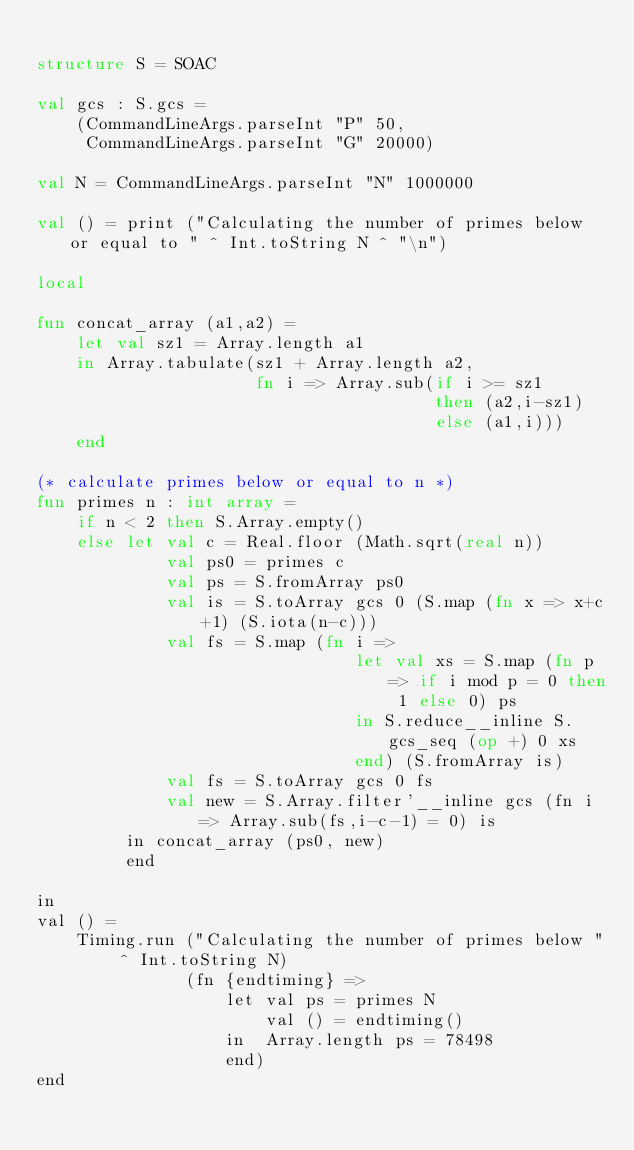Convert code to text. <code><loc_0><loc_0><loc_500><loc_500><_SML_>
structure S = SOAC

val gcs : S.gcs =
    (CommandLineArgs.parseInt "P" 50,
     CommandLineArgs.parseInt "G" 20000)

val N = CommandLineArgs.parseInt "N" 1000000

val () = print ("Calculating the number of primes below or equal to " ^ Int.toString N ^ "\n")

local

fun concat_array (a1,a2) =
    let val sz1 = Array.length a1
    in Array.tabulate(sz1 + Array.length a2,
                      fn i => Array.sub(if i >= sz1
                                        then (a2,i-sz1)
                                        else (a1,i)))
    end

(* calculate primes below or equal to n *)
fun primes n : int array =
    if n < 2 then S.Array.empty()
    else let val c = Real.floor (Math.sqrt(real n))
             val ps0 = primes c
             val ps = S.fromArray ps0
             val is = S.toArray gcs 0 (S.map (fn x => x+c+1) (S.iota(n-c)))
             val fs = S.map (fn i =>
                                let val xs = S.map (fn p => if i mod p = 0 then 1 else 0) ps
                                in S.reduce__inline S.gcs_seq (op +) 0 xs
                                end) (S.fromArray is)
             val fs = S.toArray gcs 0 fs
             val new = S.Array.filter'__inline gcs (fn i => Array.sub(fs,i-c-1) = 0) is
         in concat_array (ps0, new)
         end

in
val () =
    Timing.run ("Calculating the number of primes below " ^ Int.toString N)
               (fn {endtiming} =>
                   let val ps = primes N
                       val () = endtiming()
                   in  Array.length ps = 78498
                   end)
end
</code> 